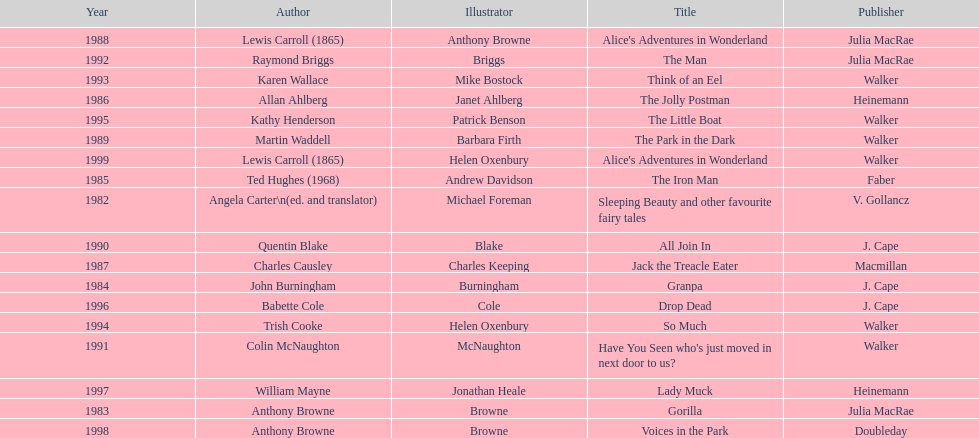How many titles were published by walker? 6. 